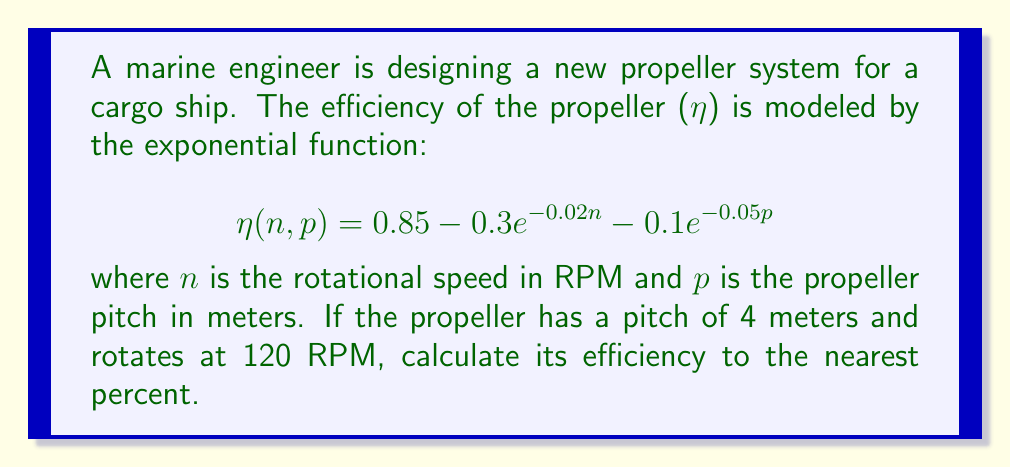What is the answer to this math problem? To solve this problem, we'll follow these steps:

1. Identify the given values:
   n = 120 RPM (rotational speed)
   p = 4 m (propeller pitch)

2. Substitute these values into the efficiency function:
   $$η(120, 4) = 0.85 - 0.3e^{-0.02(120)} - 0.1e^{-0.05(4)}$$

3. Calculate the exponents:
   $$-0.02(120) = -2.4$$
   $$-0.05(4) = -0.2$$

4. Simplify the exponential terms:
   $$η(120, 4) = 0.85 - 0.3e^{-2.4} - 0.1e^{-0.2}$$

5. Calculate the exponential values:
   $$e^{-2.4} ≈ 0.0907$$
   $$e^{-0.2} ≈ 0.8187$$

6. Substitute these values and calculate:
   $$η(120, 4) = 0.85 - 0.3(0.0907) - 0.1(0.8187)$$
   $$η(120, 4) = 0.85 - 0.02721 - 0.08187$$
   $$η(120, 4) = 0.74092$$

7. Convert to a percentage and round to the nearest percent:
   0.74092 * 100% ≈ 74%
Answer: 74% 